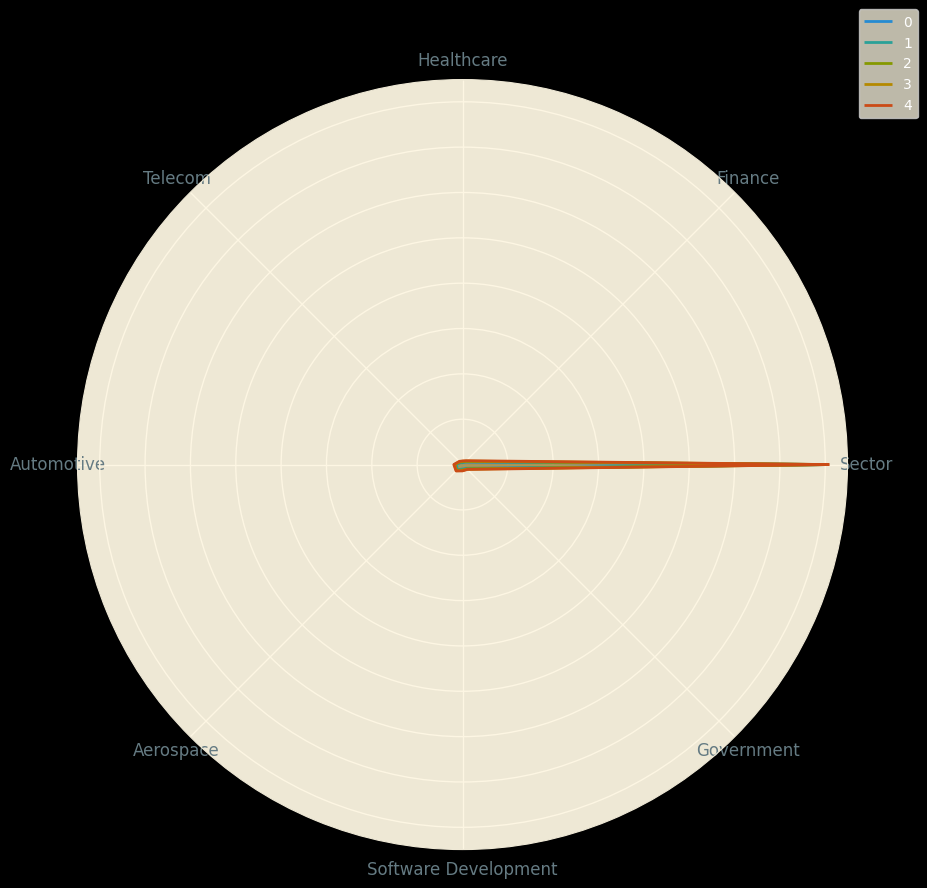Which sector had the highest adoption rate of formal verification techniques in 2022? From the radar chart, locate the data points for the year 2022 and identify the sector with the highest value.
Answer: Aerospace What is the difference in adoption rates between the Automotive and Software Development sectors in 2021? Find the values for the Automotive and Software Development sectors in 2021 on the radar chart. The difference is found by subtracting the value of Software Development from that of the Automotive sector.
Answer: 12 Which sector saw the greatest increase in adoption rates from 2018 to 2022? Examine the increase in values from 2018 to 2022 for each sector. The greatest increase is the largest positive change between these years.
Answer: Software Development What was the average adoption rate of formal verification techniques across all sectors in 2019? Calculate the sum of adoption rates for all sectors in 2019 and divide by the number of sectors (7).
Answer: 27.57 Which sector has consistently shown an increase in adoption rates every year from 2018 to 2022? Check the values for each sector year over year from 2018 to 2022 to identify which sector's values have increased every year.
Answer: All sectors In which year did the Finance sector see the most significant year-over-year increase in adoption rates? Compare the year-over-year changes in the Finance sector's adoption rates and identify the year with the greatest increase.
Answer: 2022 What is the median adoption rate across all sectors in 2020? List the adoption rate values for all sectors in 2020, order them, and find the median value (the middle value in the ordered list).
Answer: 30 Between the Healthcare and Government sectors, which had a higher adoption rate in 2020, and by how much? Locate the adoption rates for Healthcare and Government sectors in 2020, and determine the higher value and the difference between them.
Answer: Government, by 14 Which sector had the smallest variance in adoption rates from 2018 to 2022? Calculate the variance of the adoption rates for each sector from 2018 to 2022, and identify the sector with the smallest variance.
Answer: Software Development By how much did the Telecom sector's adoption rate increase from 2018 to 2022? Determine the adoption rate of the Telecom sector in 2018 and 2022 and calculate the difference between these two values.
Answer: 10 